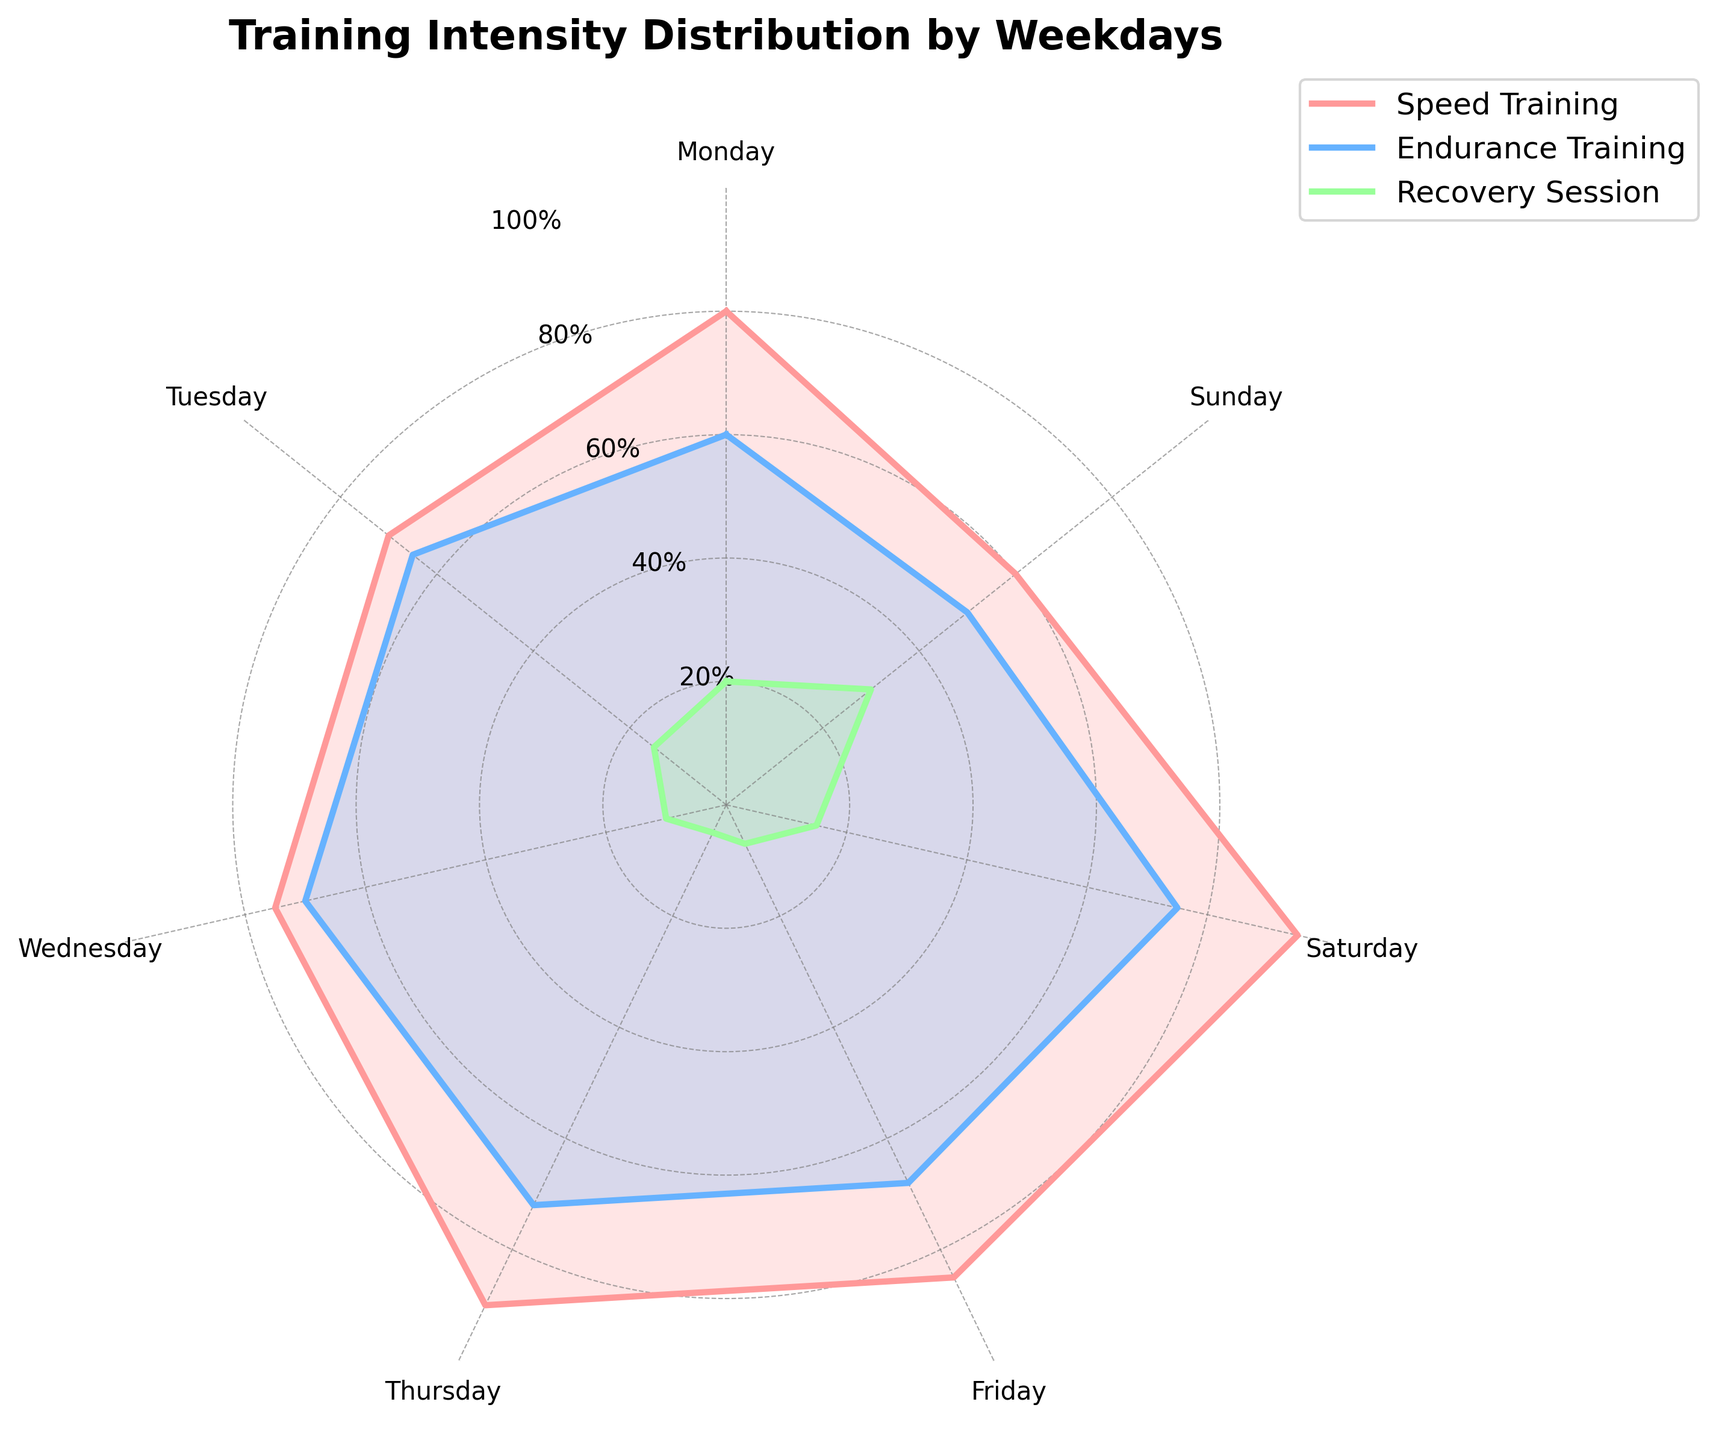What is the title of the figure? The title is usually found at the top of the chart. For this figure, it's located above the radar chart.
Answer: Training Intensity Distribution by Weekdays Which training type has the highest value on Monday? Locate the values for Monday along the three axes (Speed Training, Endurance Training, and Recovery Session). Identify the highest one.
Answer: Speed Training Which day has the highest value for Speed Training? Compare the values for Speed Training across all days of the week to find the highest one.
Answer: Saturday What is the average intensity for Endurance Training from Monday to Sunday? Sum all the Endurance Training values (60, 65, 70, 72, 68, 75, 50) and divide by the number of days (7).
Answer: (60+65+70+72+68+75+50)/7 = 65.71 How do Recovery Sessions on Tuesday compare to Thursday? Check the values for Recovery Sessions on Tuesday and Thursday (15 and 5, respectively), and compare them directly.
Answer: Higher on Tuesday On which day is Speed Training closest to Endurance Training? Calculate the difference between Speed Training and Endurance Training for each day and identify the smallest difference.
Answer: Tuesday (5%) Which day shows the largest difference between Speed Training and Recovery Session? Calculate the difference between Speed Training and Recovery Session for each day and identify the largest difference.
Answer: Thursday What percentage level are the y-ticks labeled? Look at the labels on the y-ticks, which are the concentric circles radiating outwards. They should be labeled in percentage increments.
Answer: 20%, 40%, 60%, 80%, 100% Which training type shows the greatest variation across the week? Observe the range of values for each training type (Speed Training, Endurance Training, Recovery Session) and identify the one with the largest range.
Answer: Speed Training 